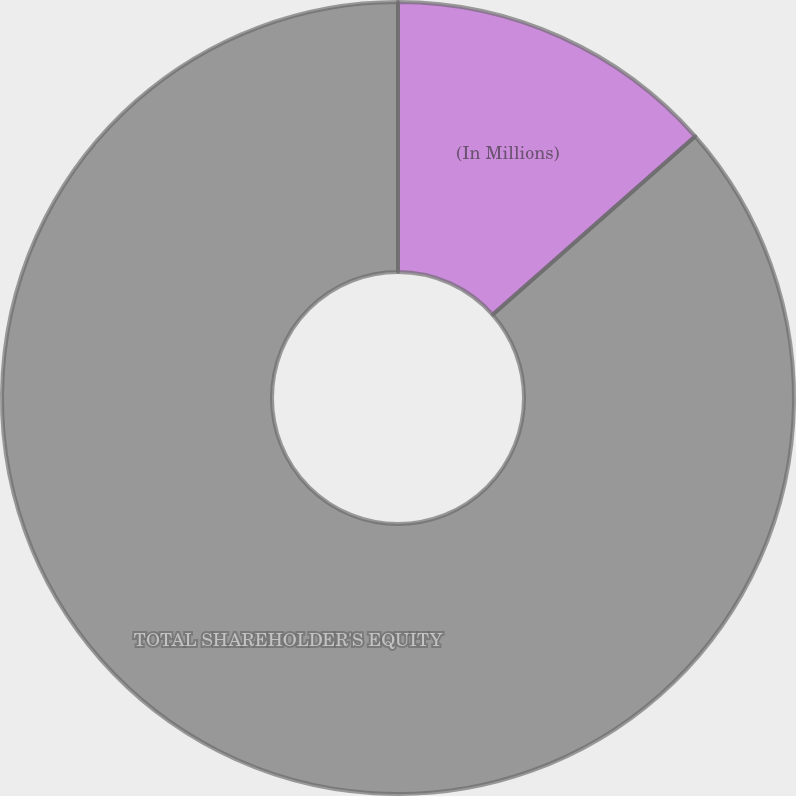Convert chart. <chart><loc_0><loc_0><loc_500><loc_500><pie_chart><fcel>(In Millions)<fcel>TOTAL SHAREHOLDER'S EQUITY<nl><fcel>13.51%<fcel>86.49%<nl></chart> 